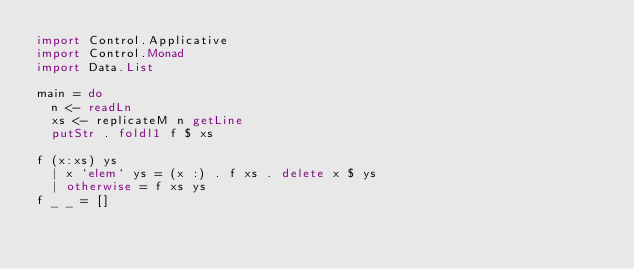Convert code to text. <code><loc_0><loc_0><loc_500><loc_500><_Haskell_>import Control.Applicative
import Control.Monad
import Data.List
 
main = do
  n <- readLn
  xs <- replicateM n getLine
  putStr . foldl1 f $ xs
 
f (x:xs) ys
  | x `elem` ys = (x :) . f xs . delete x $ ys
  | otherwise = f xs ys
f _ _ = []</code> 